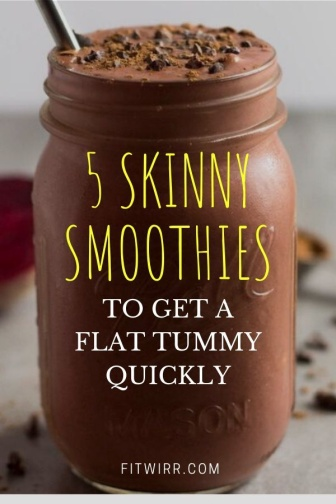Can you describe the setting where this smoothie might be enjoyed? Given the clean and simple setup, the smoothie might be enjoyed in a home kitchen where someone is conscious of their health and prefers to make their own meals and drinks. The setting could also resemble a contemporary cafe that focuses on nutritious, freshly made offerings for health-focused customers. The overall vibe suggests a place where people are mindful of what they consume and take pleasure in their food choices. 